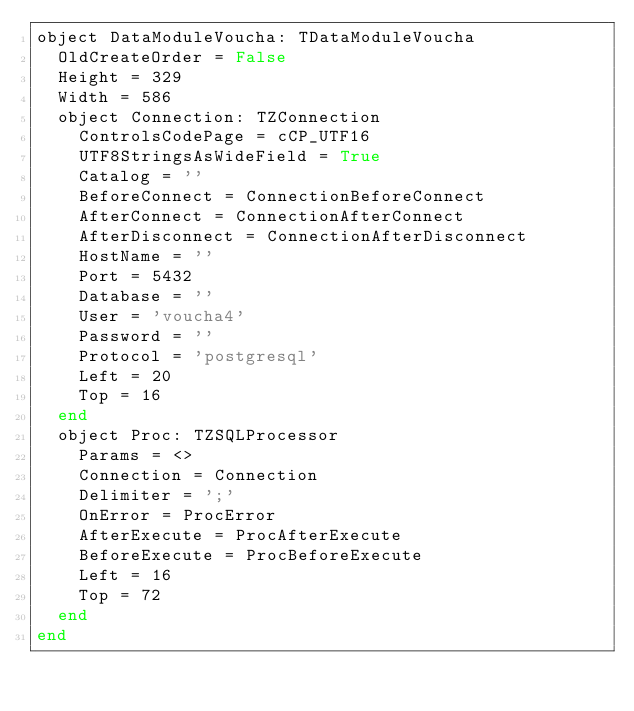Convert code to text. <code><loc_0><loc_0><loc_500><loc_500><_Pascal_>object DataModuleVoucha: TDataModuleVoucha
  OldCreateOrder = False
  Height = 329
  Width = 586
  object Connection: TZConnection
    ControlsCodePage = cCP_UTF16
    UTF8StringsAsWideField = True
    Catalog = ''
    BeforeConnect = ConnectionBeforeConnect
    AfterConnect = ConnectionAfterConnect
    AfterDisconnect = ConnectionAfterDisconnect
    HostName = ''
    Port = 5432
    Database = ''
    User = 'voucha4'
    Password = ''
    Protocol = 'postgresql'
    Left = 20
    Top = 16
  end
  object Proc: TZSQLProcessor
    Params = <>
    Connection = Connection
    Delimiter = ';'
    OnError = ProcError
    AfterExecute = ProcAfterExecute
    BeforeExecute = ProcBeforeExecute
    Left = 16
    Top = 72
  end
end
</code> 